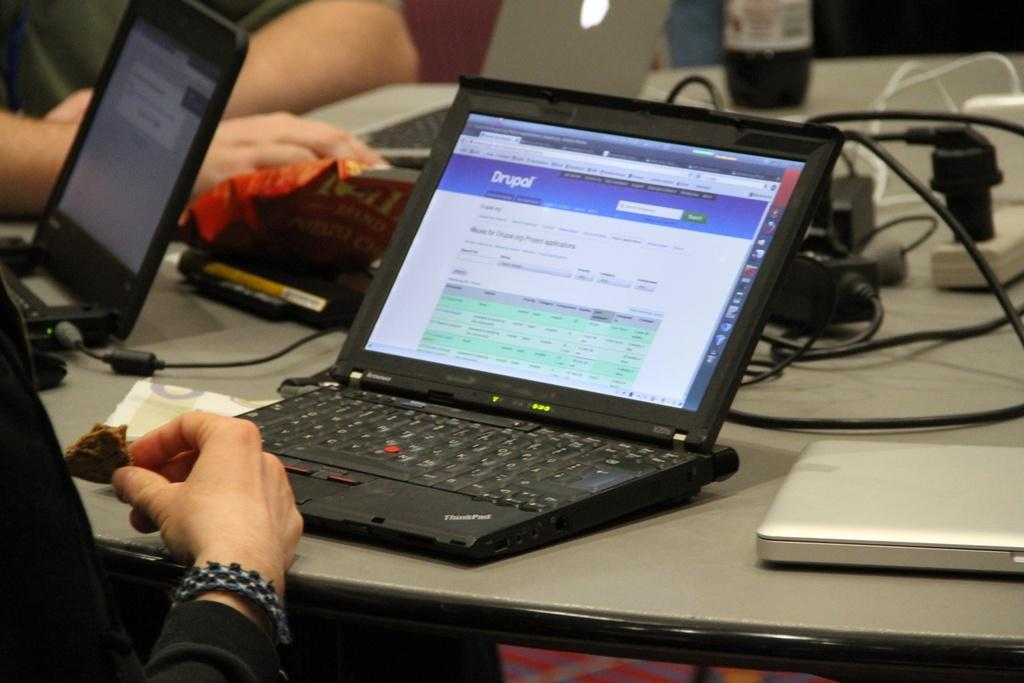<image>
Create a compact narrative representing the image presented. A person working on a computer with Drupal opened on a web page. 